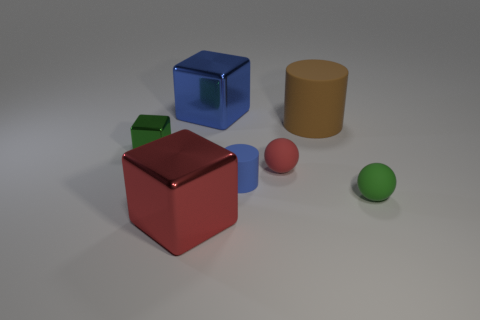Is there a big brown thing made of the same material as the blue cylinder?
Ensure brevity in your answer.  Yes. There is a tiny ball that is on the right side of the big brown rubber thing; what material is it?
Make the answer very short. Rubber. There is a matte ball that is behind the blue matte thing; is it the same color as the matte cylinder in front of the small red ball?
Provide a short and direct response. No. What is the color of the rubber cylinder that is the same size as the blue cube?
Ensure brevity in your answer.  Brown. What number of other things are there of the same shape as the brown object?
Give a very brief answer. 1. There is a shiny object that is behind the tiny green shiny object; how big is it?
Keep it short and to the point. Large. How many cubes are on the left side of the shiny object in front of the green ball?
Make the answer very short. 1. What number of other objects are there of the same size as the brown thing?
Your response must be concise. 2. Is the small cylinder the same color as the big rubber object?
Keep it short and to the point. No. There is a big metal object that is behind the big brown matte cylinder; is its shape the same as the large brown object?
Provide a short and direct response. No. 